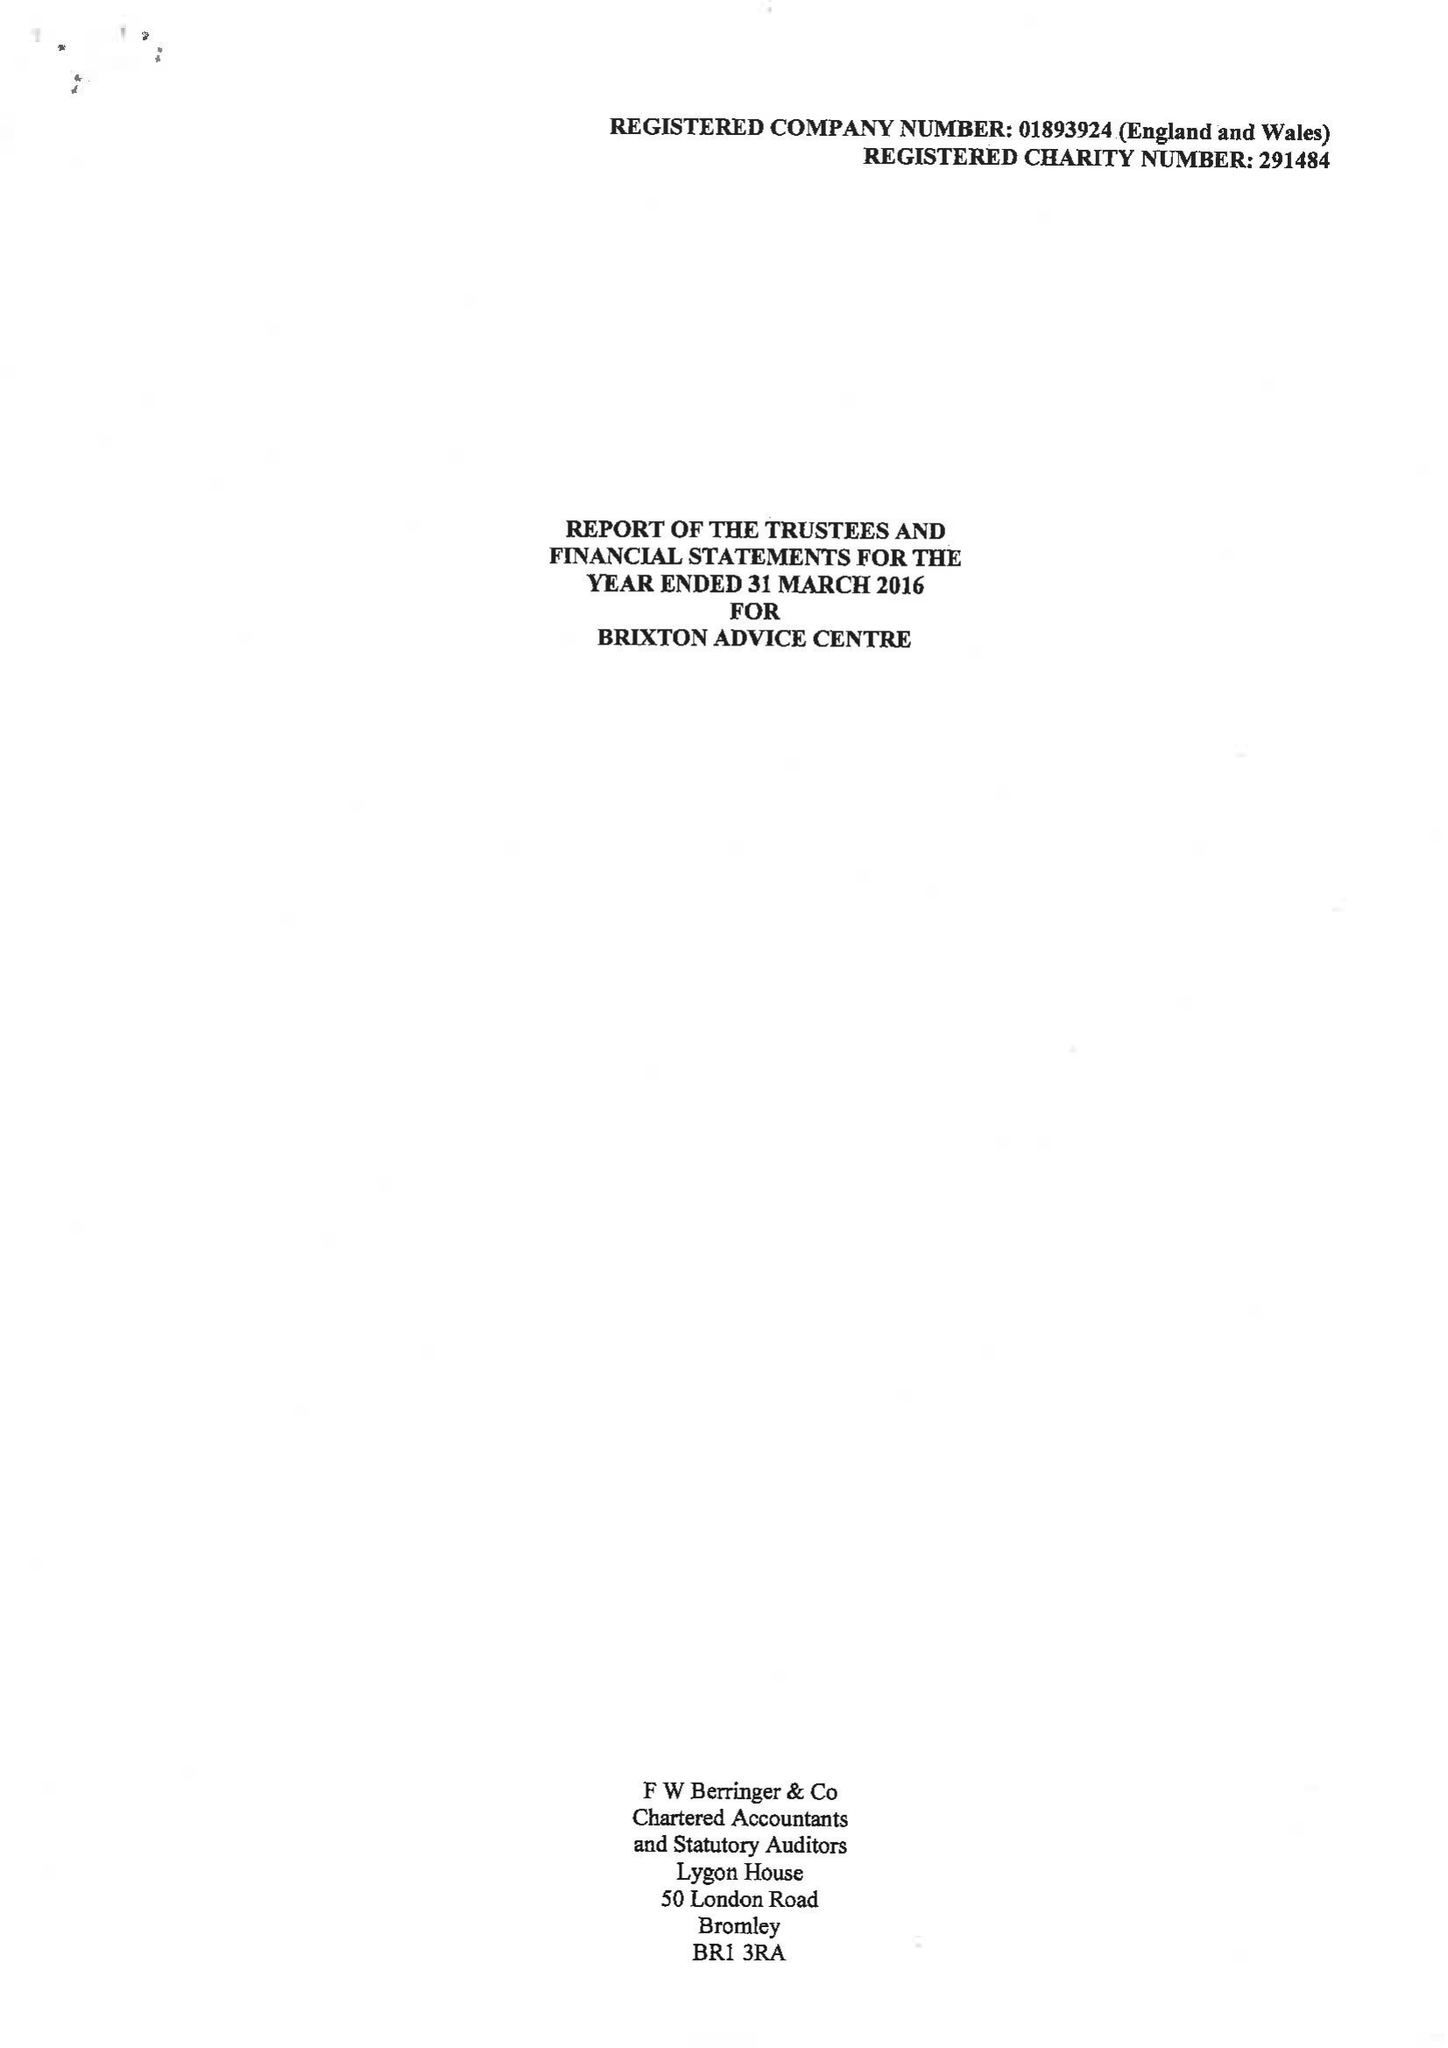What is the value for the spending_annually_in_british_pounds?
Answer the question using a single word or phrase. 497227.00 